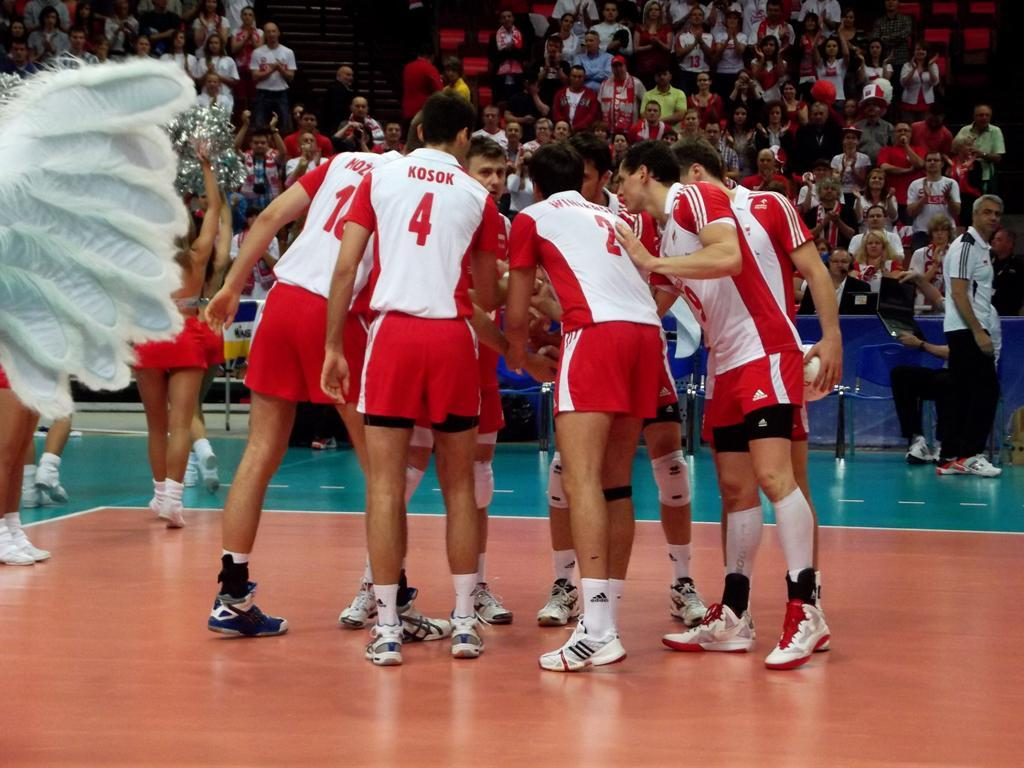Provide a one-sentence caption for the provided image. A group of male basketball players with red Jerseys that say Kosok are huddling during a game. 